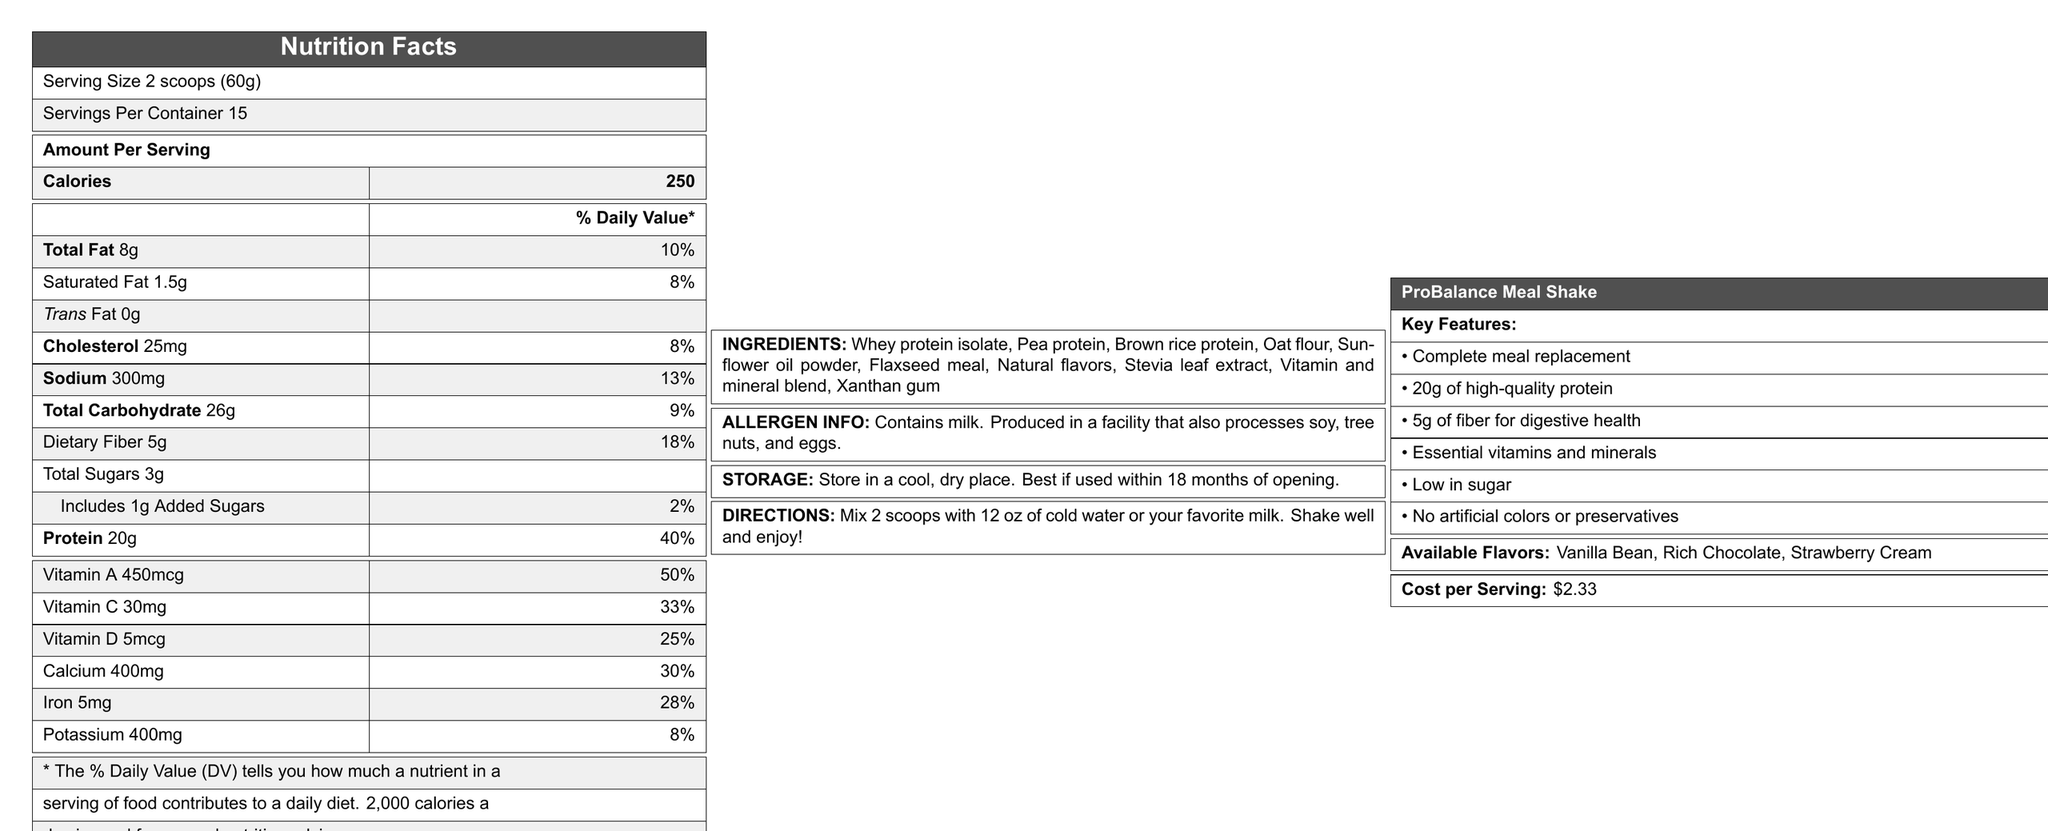What is the serving size for ProBalance Meal Shake? The document mentions that the serving size is 2 scoops which equals 60 grams.
Answer: 2 scoops (60g) How many servings are there per container? The document lists that there are 15 servings per container.
Answer: 15 How many grams of dietary fiber are in one serving? The document states that each serving contains 5 grams of dietary fiber.
Answer: 5g Which vitamin has the highest % Daily Value in the ProBalance Meal Shake? The % Daily Values for vitamins are listed, and Vitamin A has the highest at 50%.
Answer: Vitamin A (50%) What is the cost per serving? The document specifies that the cost per serving is $2.33.
Answer: $2.33 Which of the following is NOT an ingredient in the ProBalance Meal Shake? A. Whey protein isolate B. Brown rice protein C. Soy protein D. Stevia leaf extract The document lists the ingredients, and soy protein is not included.
Answer: C. Soy protein How many calories are in each serving of the ProBalance Meal Shake? A. 150 B. 200 C. 250 D. 300 The document states that each serving contains 250 calories.
Answer: C. 250 Does the ProBalance Meal Shake contain any allergens? The document indicates that it contains milk and is produced in a facility that processes soy, tree nuts, and eggs.
Answer: Yes Describe the key features of the ProBalance Meal Shake. The document provides a bullet-point list of the key features emphasizing protein content, fiber, vitamins and minerals, low sugar content, and the absence of artificial additives.
Answer: The ProBalance Meal Shake is a complete meal replacement that contains 20g of high-quality protein, 5g of fiber for digestive health, essential vitamins and minerals, is low in sugar, and contains no artificial colors or preservatives. How many grams of protein are there per serving? The document lists the protein content for each serving as 20 grams.
Answer: 20g What flavors are available for the ProBalance Meal Shake? The document lists the available flavors under the key features section.
Answer: Vanilla Bean, Rich Chocolate, Strawberry Cream What instructions are given for preparing the ProBalance Meal Shake? The document specifies the preparation instructions clearly.
Answer: Mix 2 scoops with 12 oz of cold water or your favorite milk. Shake well and enjoy! What is the daily value percentage of iron per serving of ProBalance Meal Shake? The document lists the iron content and its % Daily Value as 28%.
Answer: 28% What is the total carbohydrate content per serving? The document states that each serving contains 26 grams of total carbohydrates.
Answer: 26g Can the document specify how the ProBalance Meal Shake affects weight loss? The document provides nutrition facts and key features but does not discuss specifics about weight loss effects.
Answer: Not enough information 